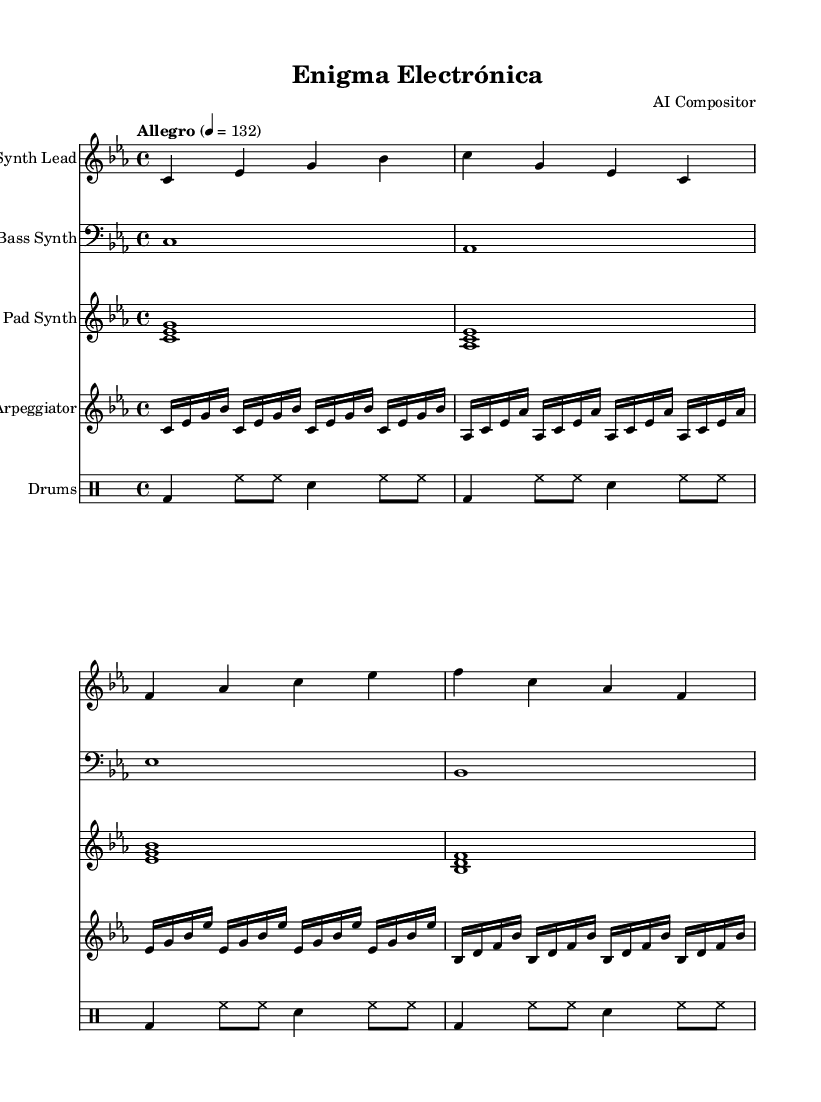What is the key signature of this music? The key signature is C minor, which features three flats. This can be determined from the information provided in the global context of the sheet music.
Answer: C minor What is the time signature of this music? The time signature is 4/4, indicated in the global context of the sheet music. This means there are four beats in each measure.
Answer: 4/4 What is the tempo marking of this piece? The tempo marking is "Allegro," which indicates a fast tempo. The exact metronome marking of 132 aligns with the tempo marking seen in the global context.
Answer: Allegro How many measures are there in the synth lead section? There are four measures in the synth lead section, which can be counted from the line breaks in the synthLead notation, each separated by a vertical bar.
Answer: 4 What is the role of the arpeggiator in this piece? The arpeggiator serves to provide a rhythmic and melodic texture that complements the other instruments. It uses a repeating pattern, which creates a sense of movement throughout the piece.
Answer: Rhythmic and melodic texture How does the bass synth differ from the synth lead? The bass synth plays longer, sustained notes (whole notes) in the lower register, while the synth lead plays shorter, more melodic phrases in the higher register. This contrast provides depth and dimension to the overall sound.
Answer: Sustained lower notes vs. shorter higher phrases What specific instruments are used in this soundtrack? The specific instruments used are a synth lead, bass synth, pad synth, arpeggiator, and drums. This is detailed in the score section where each instrument is listed.
Answer: Synth lead, bass synth, pad synth, arpeggiator, drums 